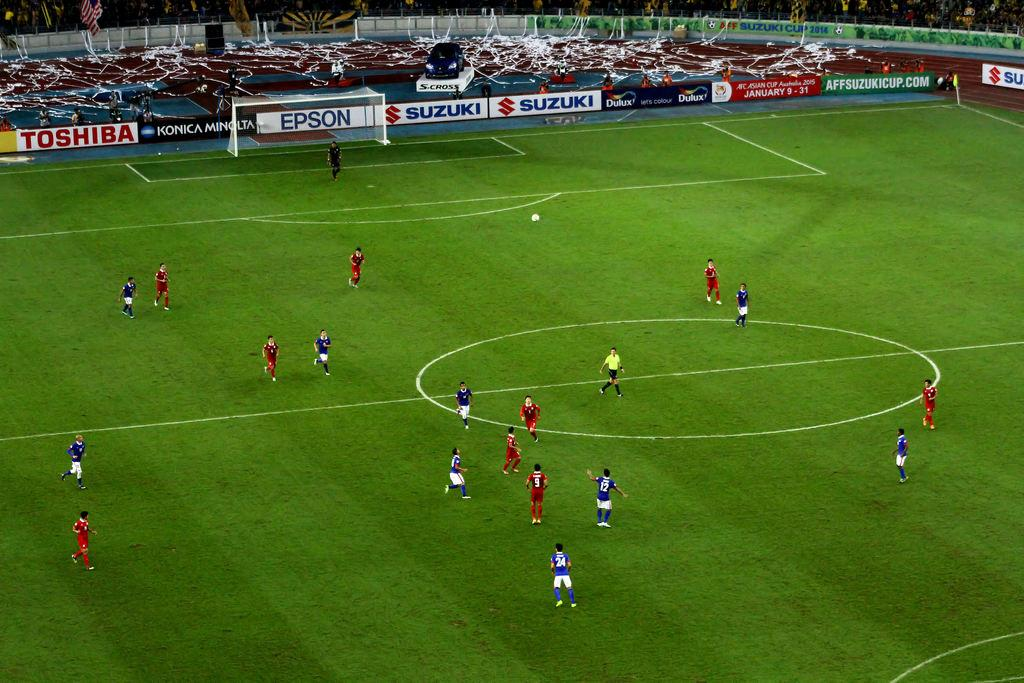<image>
Present a compact description of the photo's key features. Soccer players in a game at a stadium with banners from Toshiba, Konica Minolta, Epson and Suzuki. 